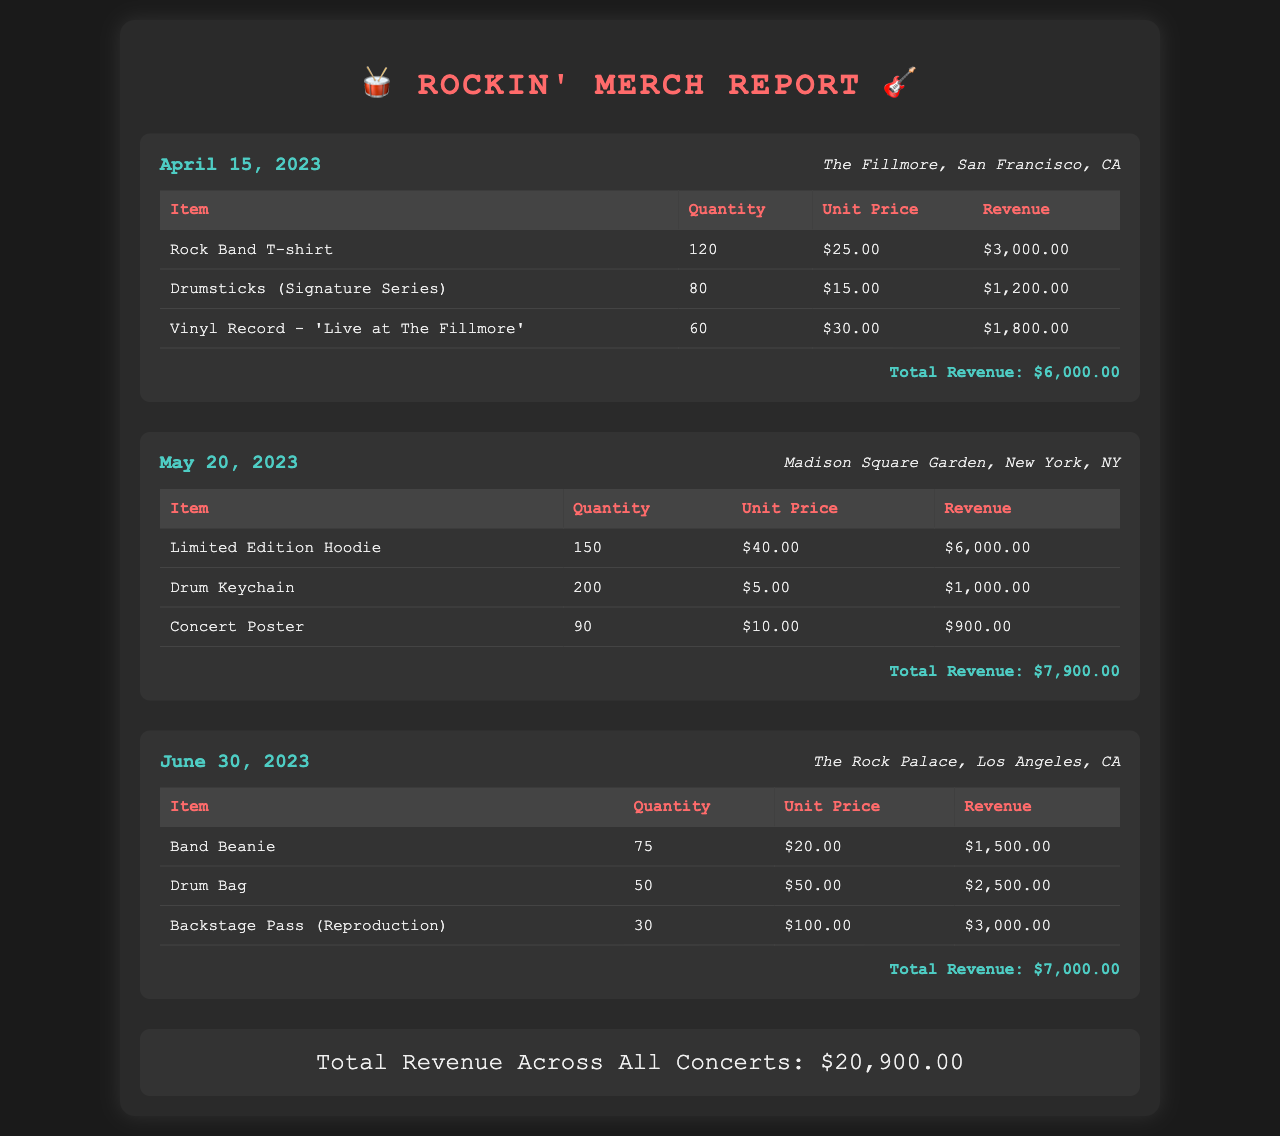What was the total revenue for the concert on April 15, 2023? The total revenue for this concert is specifically mentioned in the document as $6,000.00.
Answer: $6,000.00 How many Limited Edition Hoodies were sold? The quantity sold of Limited Edition Hoodies is clearly shown in the respective concert section as 150.
Answer: 150 What item generated the highest revenue in the June 30, 2023 concert? After comparing the revenue of all items sold at that concert, the Backstage Pass (Reproduction) generated the highest revenue of $3,000.00.
Answer: Backstage Pass (Reproduction) What is the total revenue across all concerts? The document provides a summary statement at the end indicating the total revenue from all concerts, which is $20,900.00.
Answer: $20,900.00 How much did the Drumsticks (Signature Series) cost per unit? The unit price for the Drumsticks (Signature Series) is specified in the document as $15.00.
Answer: $15.00 How many items were sold during the concert at Madison Square Garden? By adding the quantities sold of each item in that concert, we find a total of 440 items sold.
Answer: 440 What was the venue for the concert on June 30, 2023? The venue for this concert is explicitly mentioned as The Rock Palace, Los Angeles, CA.
Answer: The Rock Palace, Los Angeles, CA Which item had the lowest unit price at The Fillmore concert? By reviewing the unit prices of all items sold at The Fillmore concert, Drumsticks (Signature Series) had the lowest unit price of $15.00.
Answer: Drumsticks (Signature Series) 